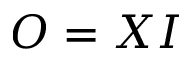Convert formula to latex. <formula><loc_0><loc_0><loc_500><loc_500>O = X I</formula> 